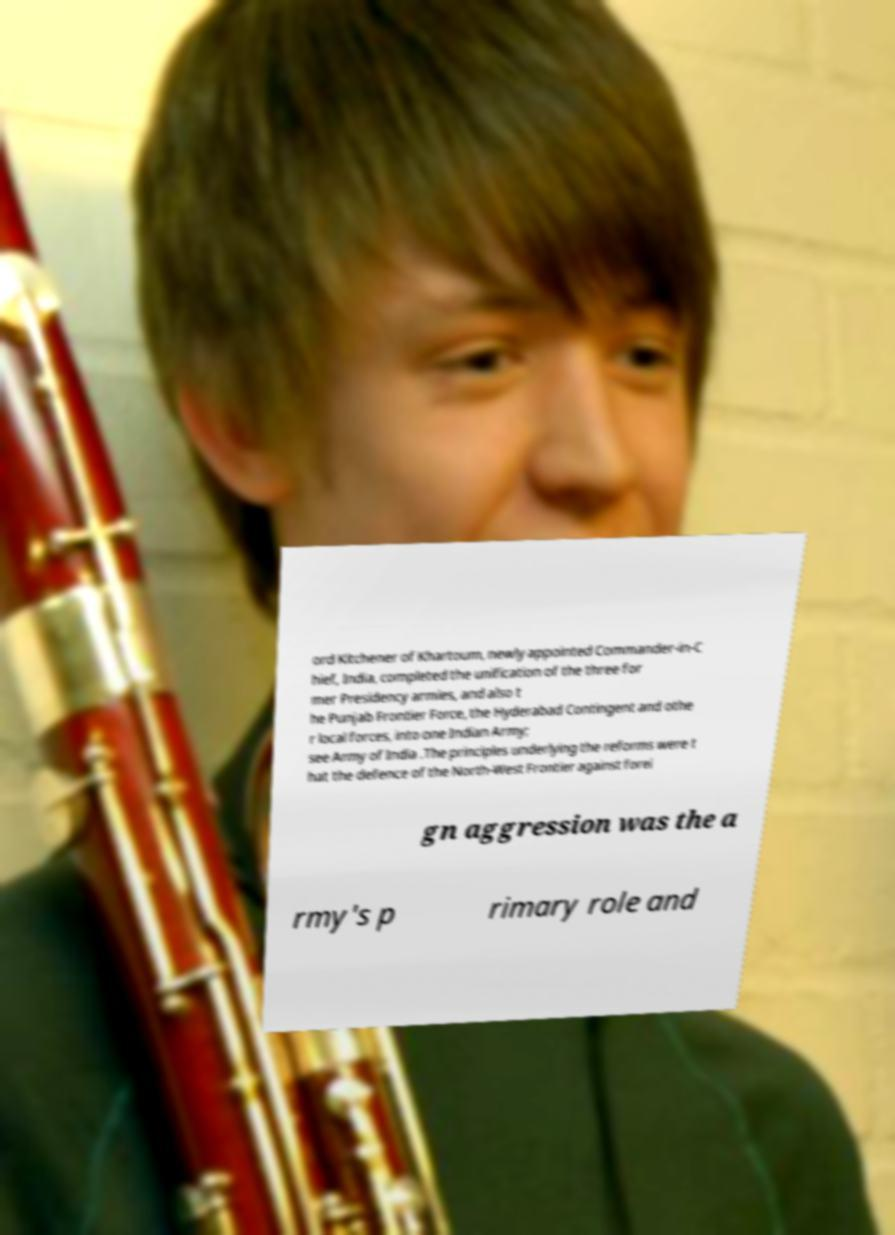I need the written content from this picture converted into text. Can you do that? ord Kitchener of Khartoum, newly appointed Commander-in-C hief, India, completed the unification of the three for mer Presidency armies, and also t he Punjab Frontier Force, the Hyderabad Contingent and othe r local forces, into one Indian Army; see Army of India .The principles underlying the reforms were t hat the defence of the North-West Frontier against forei gn aggression was the a rmy's p rimary role and 